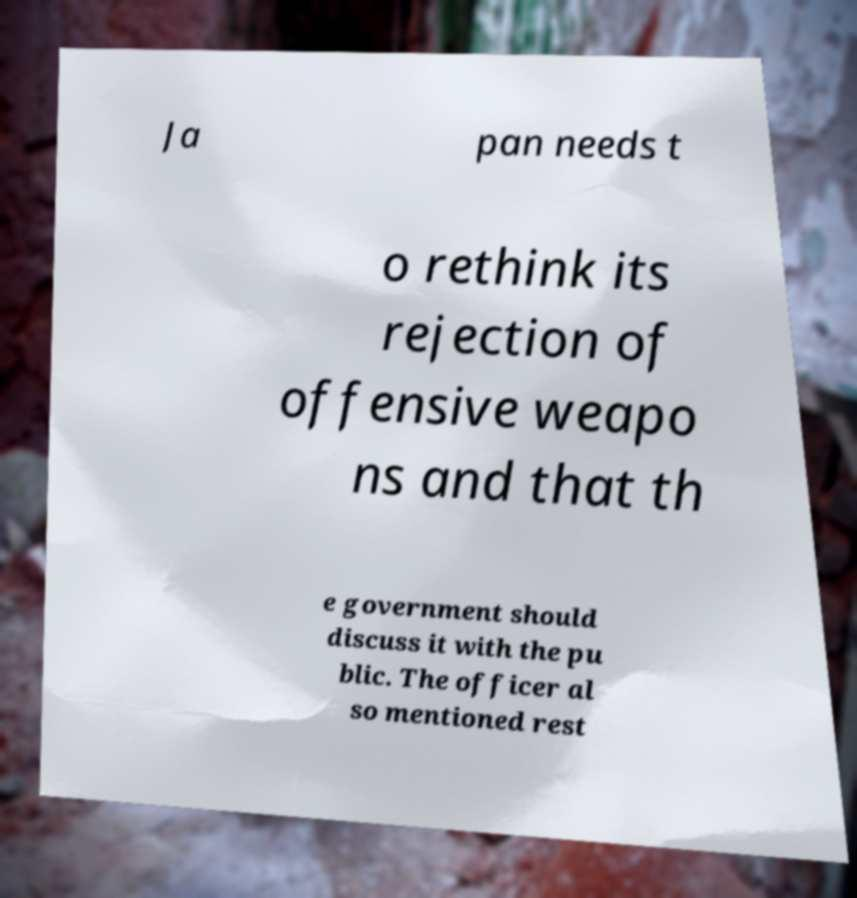Can you read and provide the text displayed in the image?This photo seems to have some interesting text. Can you extract and type it out for me? Ja pan needs t o rethink its rejection of offensive weapo ns and that th e government should discuss it with the pu blic. The officer al so mentioned rest 